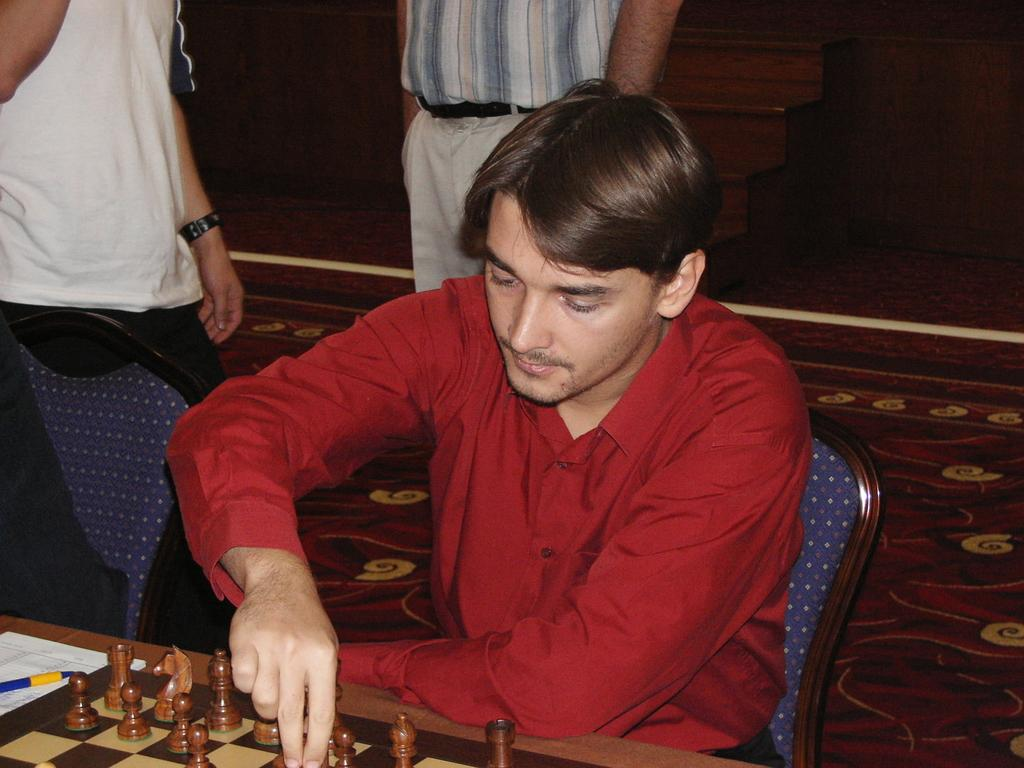What is the man in the image doing? The man is seated and playing chess on a table. Can you describe the table in the image? The table is where the man is playing chess. How many people are standing near the man? There are two people standing near the man. What type of cream is being applied to the man's wound in the image? There is no cream or wound present in the image; the man is playing chess on a table. Can you describe the kiss between the two people standing near the man? There is no kiss between the two people standing near the man in the image; they are simply standing nearby. 